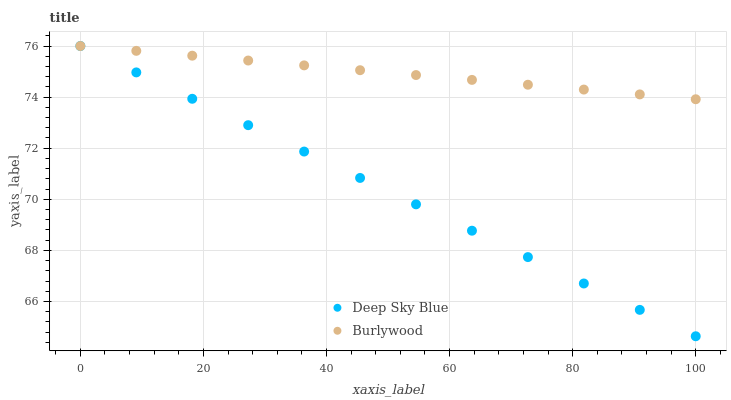Does Deep Sky Blue have the minimum area under the curve?
Answer yes or no. Yes. Does Burlywood have the maximum area under the curve?
Answer yes or no. Yes. Does Deep Sky Blue have the maximum area under the curve?
Answer yes or no. No. Is Deep Sky Blue the smoothest?
Answer yes or no. Yes. Is Burlywood the roughest?
Answer yes or no. Yes. Is Deep Sky Blue the roughest?
Answer yes or no. No. Does Deep Sky Blue have the lowest value?
Answer yes or no. Yes. Does Deep Sky Blue have the highest value?
Answer yes or no. Yes. Does Deep Sky Blue intersect Burlywood?
Answer yes or no. Yes. Is Deep Sky Blue less than Burlywood?
Answer yes or no. No. Is Deep Sky Blue greater than Burlywood?
Answer yes or no. No. 